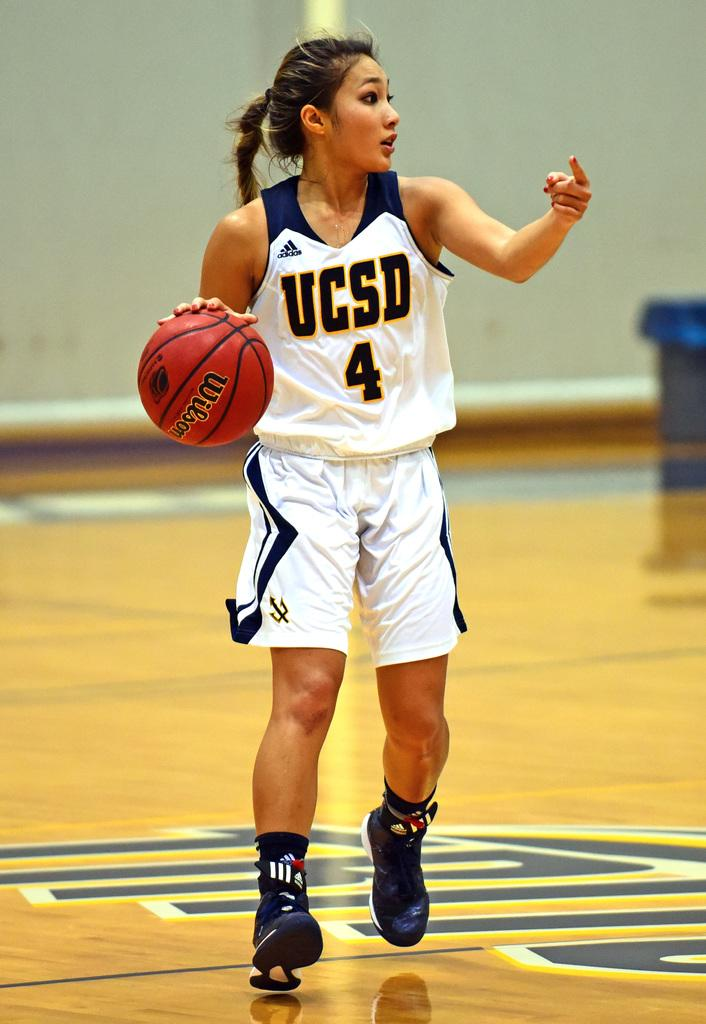<image>
Summarize the visual content of the image. UCSD player number four points to one of her teammates to indicate where they should go. 